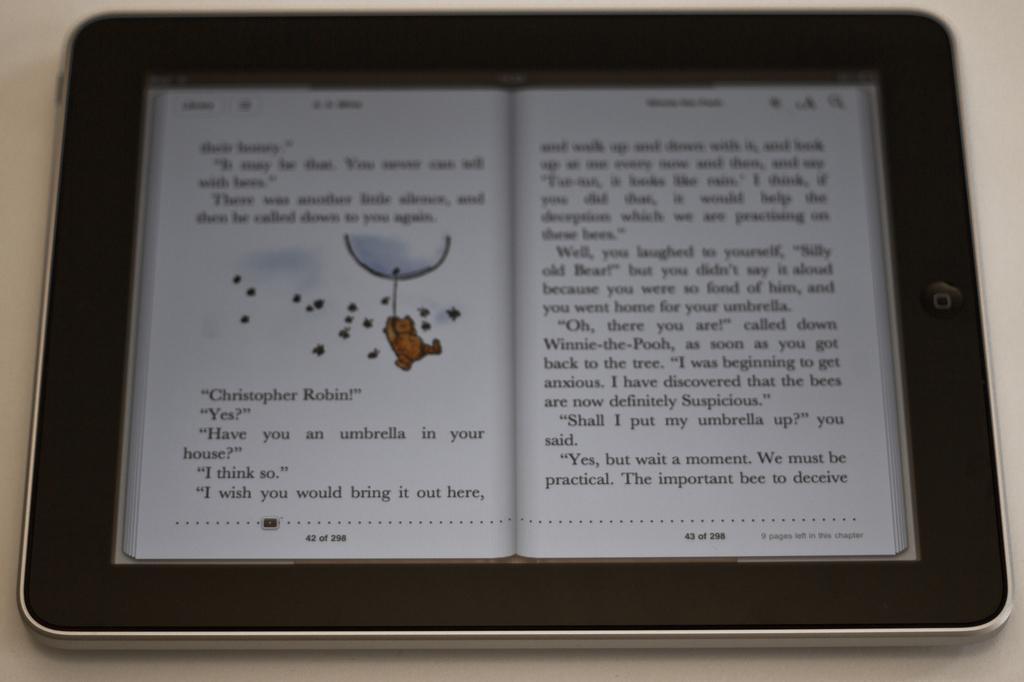<image>
Write a terse but informative summary of the picture. An iPad has a digital book on it with the words "Christopher Robin!" under an illustration on one of the pages. 